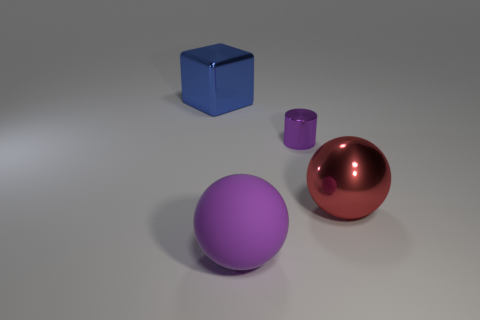Can you describe the setting in which these objects are placed? Certainly! The objects are situated in a simple, uncluttered space that seems to be artificially lit, possibly within a studio environment. The lighting creates subtle shadows, imparting a sense of depth and dimension to the composition. 